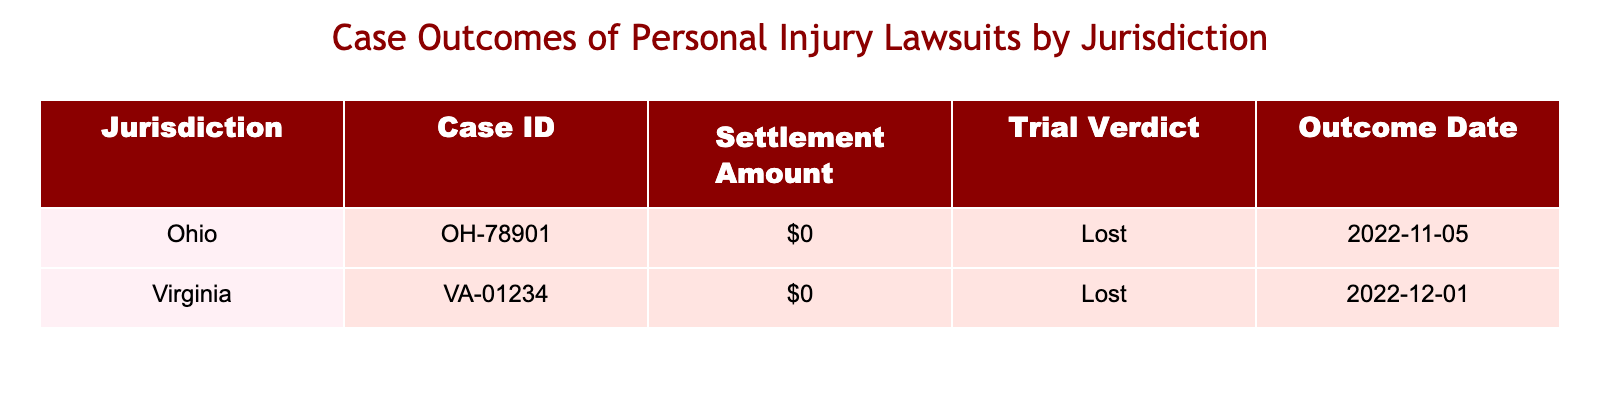What are the outcomes for the cases listed in the table? The table shows two cases, both of which resulted in a "Lost" outcome.
Answer: Lost Which jurisdiction has a case with a settlement amount of $0? Both listed jurisdictions, Ohio and Virginia, have case IDs that show a settlement amount of $0.
Answer: Ohio and Virginia How many cases resulted in a settlement amount greater than $0? There are no cases with a settlement amount greater than $0, as both cases show $0.
Answer: 0 Is there any case in the Ohio jurisdiction that was won? The outcome for the case in the Ohio jurisdiction was "Lost," indicating it was not won.
Answer: No What is the difference in the number of cases between Ohio and Virginia? Both jurisdictions have one case each, so the difference in the number of cases is 0.
Answer: 0 Which outcome occurred first based on the outcome date? The case in Ohio has an outcome date of November 5, 2022, while the case in Virginia has an outcome date of December 1, 2022. Therefore, Ohio's case was first.
Answer: Ohio Based on the table data, what percentage of the cases were lost? There are two cases listed, and both were lost. Therefore, the percentage of lost cases is (2/2)*100 = 100%.
Answer: 100% If we had one more case in Virginia that was won, what would the total outcomes be? Currently, there are two lost outcomes. Adding one won case in Virginia would change the total outcomes to one win and two losses.
Answer: 1 win, 2 losses 